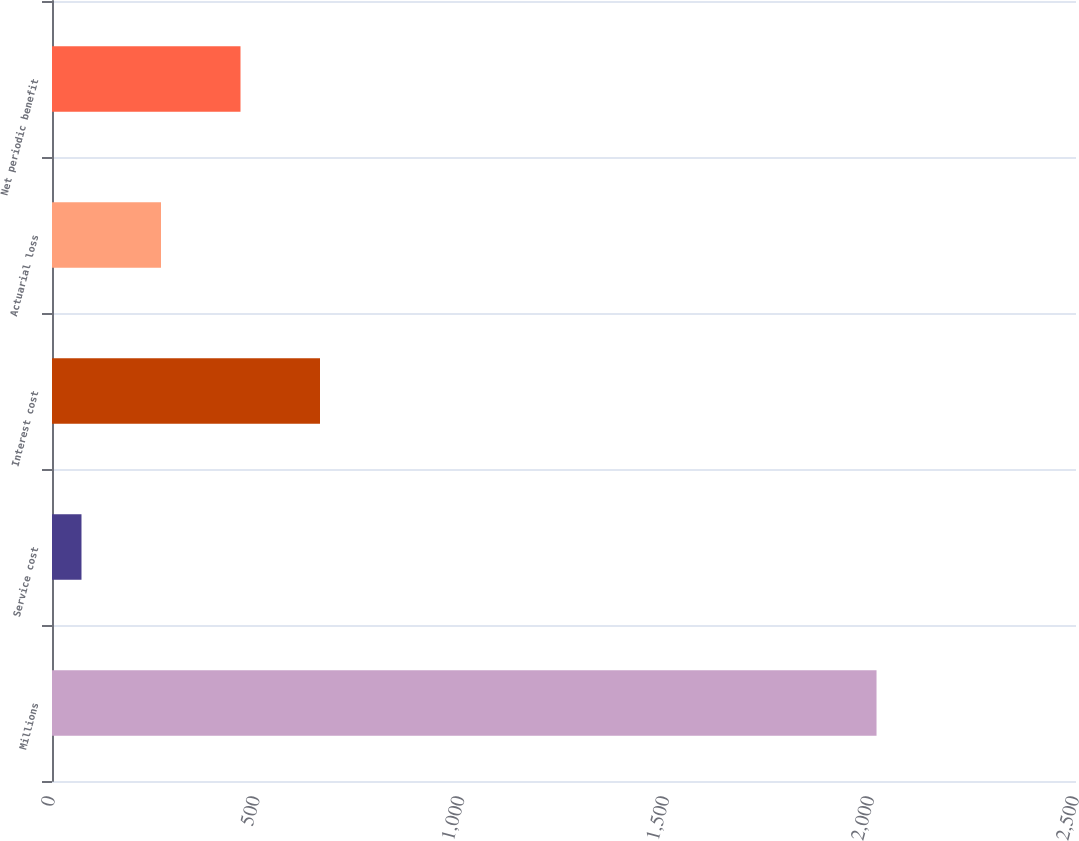<chart> <loc_0><loc_0><loc_500><loc_500><bar_chart><fcel>Millions<fcel>Service cost<fcel>Interest cost<fcel>Actuarial loss<fcel>Net periodic benefit<nl><fcel>2013<fcel>72<fcel>654.3<fcel>266.1<fcel>460.2<nl></chart> 